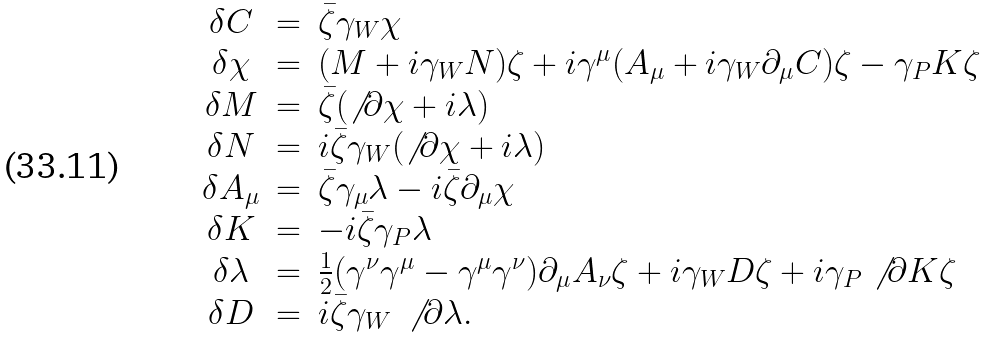<formula> <loc_0><loc_0><loc_500><loc_500>\begin{array} { c c l } \delta C & = & \bar { \zeta } \gamma _ { W } \chi \\ \delta \chi & = & ( M + i \gamma _ { W } N ) \zeta + i \gamma ^ { \mu } ( A _ { \mu } + i \gamma _ { W } \partial _ { \mu } C ) \zeta - \gamma _ { P } K \zeta \\ \delta M & = & \bar { \zeta } ( \not \, \partial \chi + i \lambda ) \\ \delta N & = & i \bar { \zeta } \gamma _ { W } ( \not \, \partial \chi + i \lambda ) \\ \delta A _ { \mu } & = & \bar { \zeta } \gamma _ { \mu } \lambda - i \bar { \zeta } \partial _ { \mu } \chi \\ \delta K & = & - i \bar { \zeta } \gamma _ { P } \lambda \\ \delta \lambda & = & \frac { 1 } { 2 } ( \gamma ^ { \nu } \gamma ^ { \mu } - \gamma ^ { \mu } \gamma ^ { \nu } ) \partial _ { \mu } A _ { \nu } \zeta + i \gamma _ { W } D \zeta + i \gamma _ { P } \not \, \partial K \zeta \\ \delta D & = & i \bar { \zeta } \gamma _ { W } \, \not \, \partial \lambda . \end{array}</formula> 